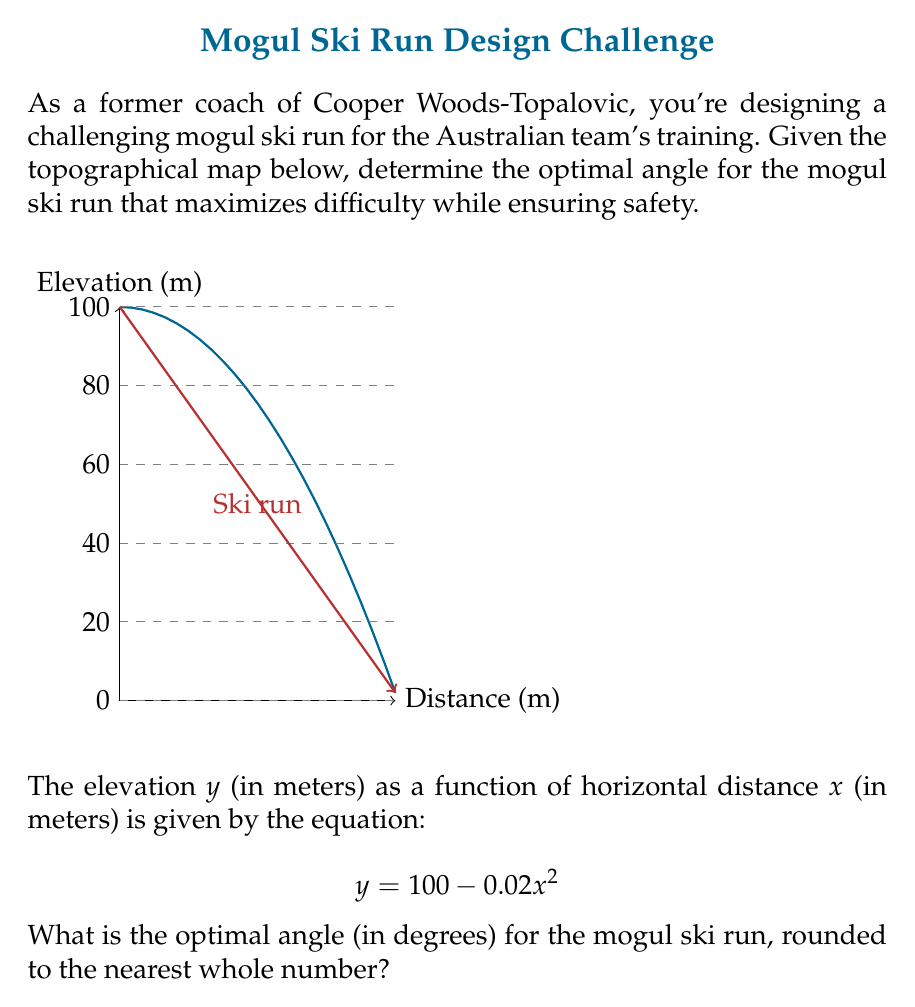Solve this math problem. To find the optimal angle for the mogul ski run, we need to calculate the slope of the run and convert it to an angle. Here's how we can do this step-by-step:

1) The slope of the run is given by the derivative of the elevation function:
   $$\frac{dy}{dx} = -0.04x$$

2) To find the steepest point (optimal angle), we need to evaluate this at the start of the run where $x = 0$:
   $$\text{Slope} = -0.04 \cdot 0 = 0$$

3) However, this gives us a flat slope, which isn't suitable for a mogul run. Instead, let's consider the average slope over the entire run.

4) The run ends at $x = 70$ (from the graph). At this point:
   $$y = 100 - 0.02(70)^2 = 100 - 98 = 2$$

5) The average slope is:
   $$\text{Slope} = \frac{\text{Change in elevation}}{\text{Change in horizontal distance}} = \frac{100 - 2}{70} = \frac{98}{70} \approx 1.4$$

6) To convert this slope to an angle, we use the arctangent function:
   $$\theta = \arctan(1.4) \approx 54.46^\circ$$

7) Rounding to the nearest whole number:
   $$\theta \approx 54^\circ$$

This angle provides a challenging yet safe mogul run, suitable for high-level training like that of Cooper Woods-Topalovic.
Answer: 54° 